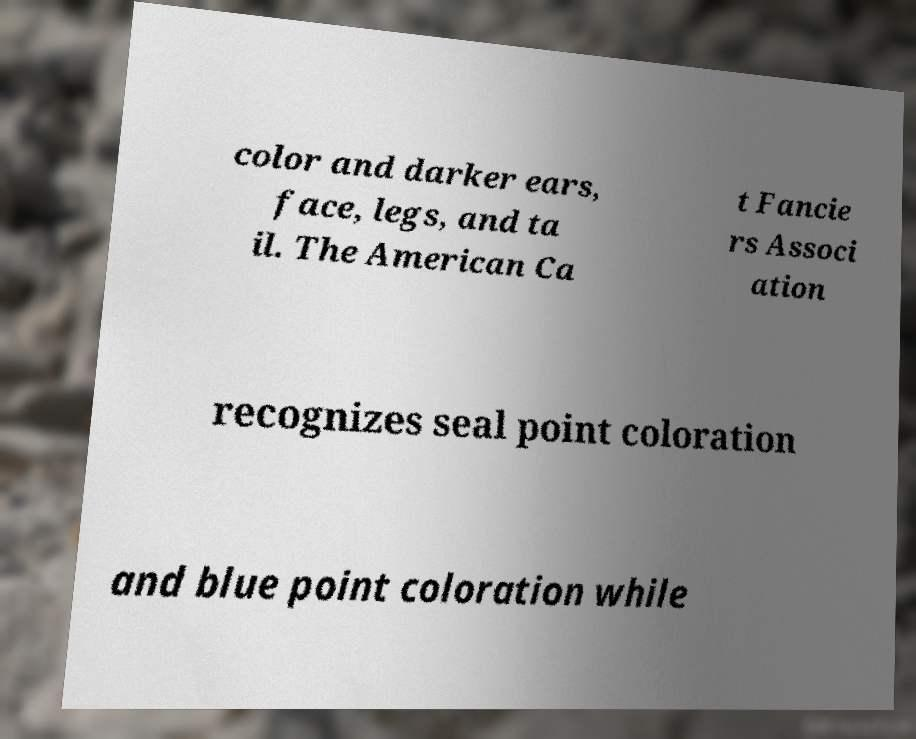Can you accurately transcribe the text from the provided image for me? color and darker ears, face, legs, and ta il. The American Ca t Fancie rs Associ ation recognizes seal point coloration and blue point coloration while 